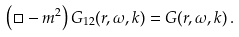<formula> <loc_0><loc_0><loc_500><loc_500>\left ( \Box - m ^ { 2 } \right ) G _ { 1 2 } ( r , \omega , { k } ) = G ( r , \omega , { k } ) \, .</formula> 